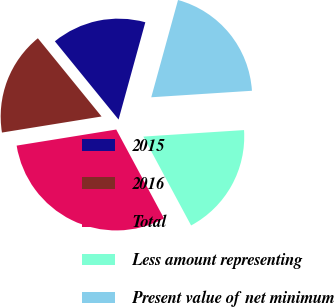Convert chart to OTSL. <chart><loc_0><loc_0><loc_500><loc_500><pie_chart><fcel>2015<fcel>2016<fcel>Total<fcel>Less amount representing<fcel>Present value of net minimum<nl><fcel>15.15%<fcel>16.67%<fcel>30.3%<fcel>18.18%<fcel>19.7%<nl></chart> 